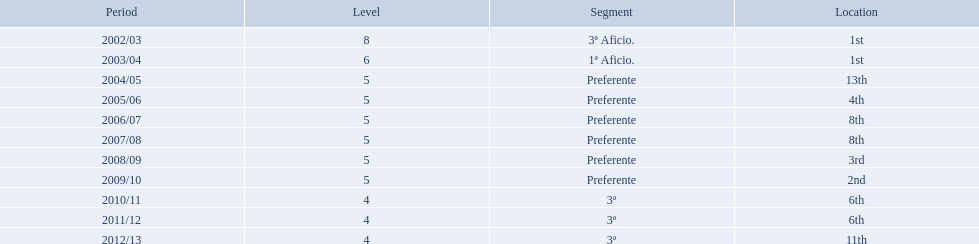What place did the team place in 2010/11? 6th. In what other year did they place 6th? 2011/12. 